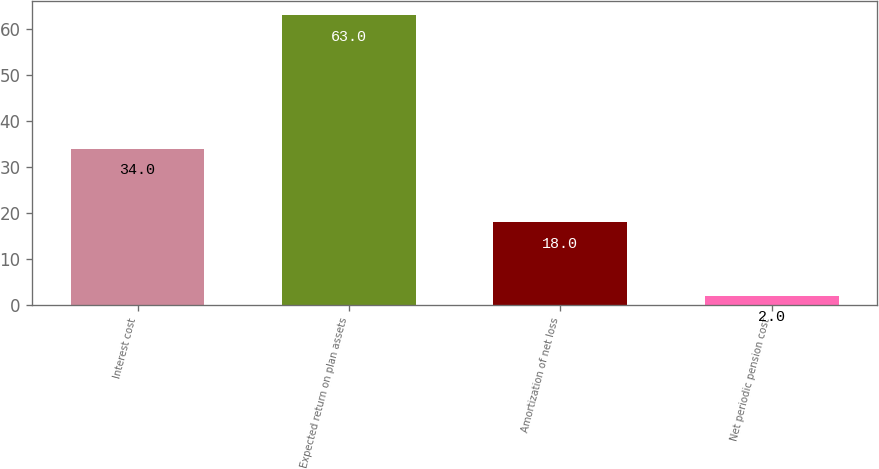Convert chart to OTSL. <chart><loc_0><loc_0><loc_500><loc_500><bar_chart><fcel>Interest cost<fcel>Expected return on plan assets<fcel>Amortization of net loss<fcel>Net periodic pension cost<nl><fcel>34<fcel>63<fcel>18<fcel>2<nl></chart> 